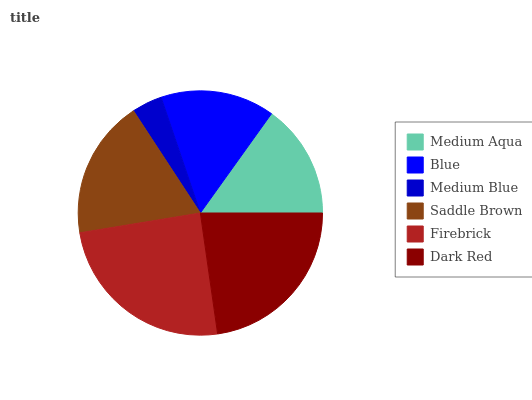Is Medium Blue the minimum?
Answer yes or no. Yes. Is Firebrick the maximum?
Answer yes or no. Yes. Is Blue the minimum?
Answer yes or no. No. Is Blue the maximum?
Answer yes or no. No. Is Medium Aqua greater than Blue?
Answer yes or no. Yes. Is Blue less than Medium Aqua?
Answer yes or no. Yes. Is Blue greater than Medium Aqua?
Answer yes or no. No. Is Medium Aqua less than Blue?
Answer yes or no. No. Is Saddle Brown the high median?
Answer yes or no. Yes. Is Medium Aqua the low median?
Answer yes or no. Yes. Is Blue the high median?
Answer yes or no. No. Is Saddle Brown the low median?
Answer yes or no. No. 